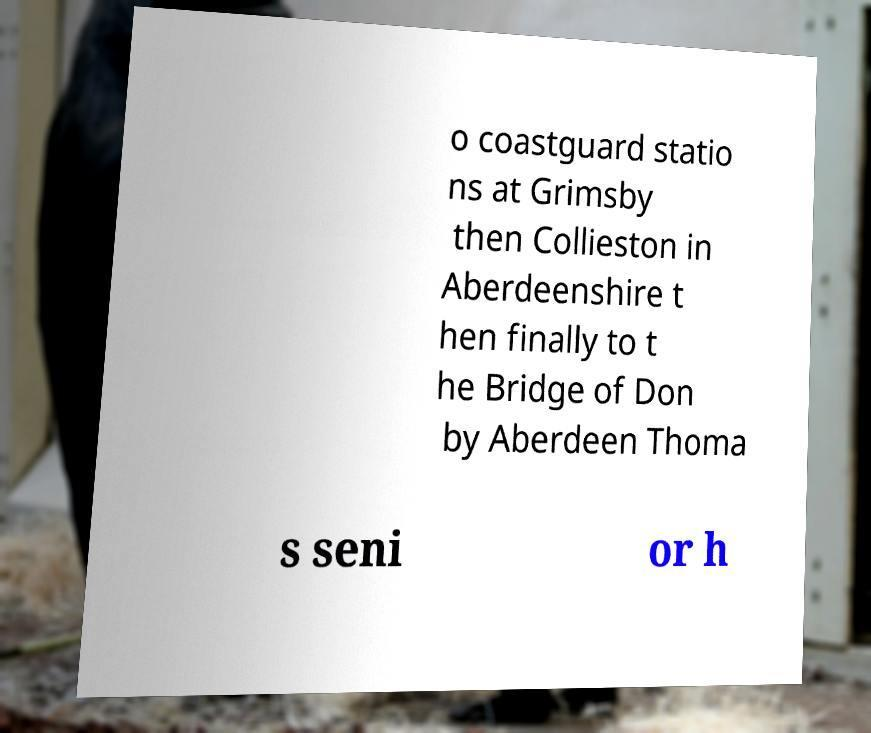Please read and relay the text visible in this image. What does it say? o coastguard statio ns at Grimsby then Collieston in Aberdeenshire t hen finally to t he Bridge of Don by Aberdeen Thoma s seni or h 